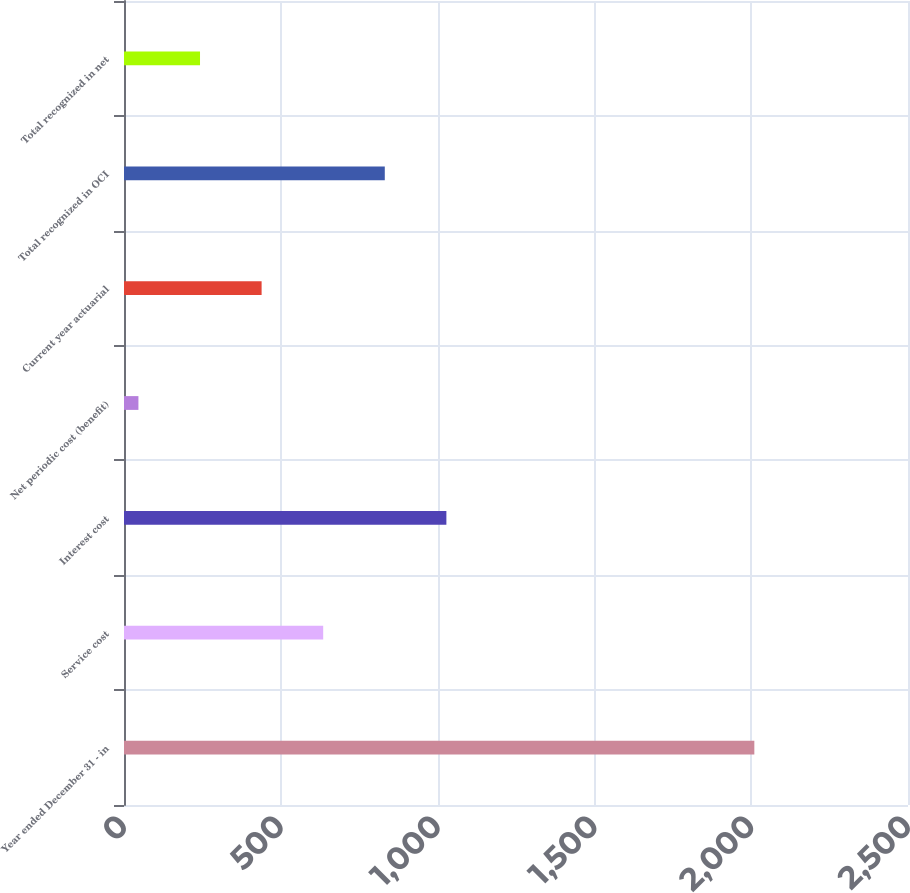Convert chart to OTSL. <chart><loc_0><loc_0><loc_500><loc_500><bar_chart><fcel>Year ended December 31 - in<fcel>Service cost<fcel>Interest cost<fcel>Net periodic cost (benefit)<fcel>Current year actuarial<fcel>Total recognized in OCI<fcel>Total recognized in net<nl><fcel>2010<fcel>635.2<fcel>1028<fcel>46<fcel>438.8<fcel>831.6<fcel>242.4<nl></chart> 